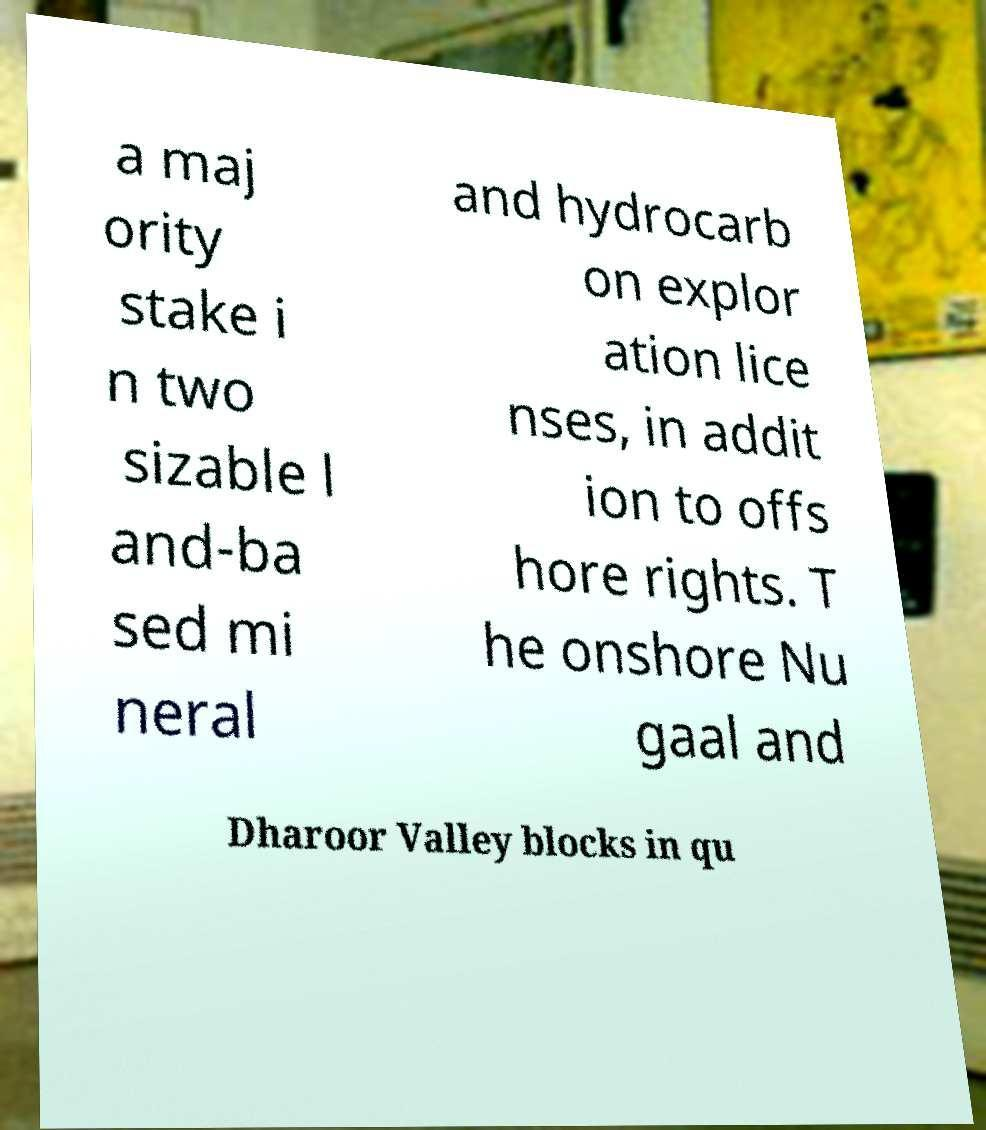I need the written content from this picture converted into text. Can you do that? a maj ority stake i n two sizable l and-ba sed mi neral and hydrocarb on explor ation lice nses, in addit ion to offs hore rights. T he onshore Nu gaal and Dharoor Valley blocks in qu 